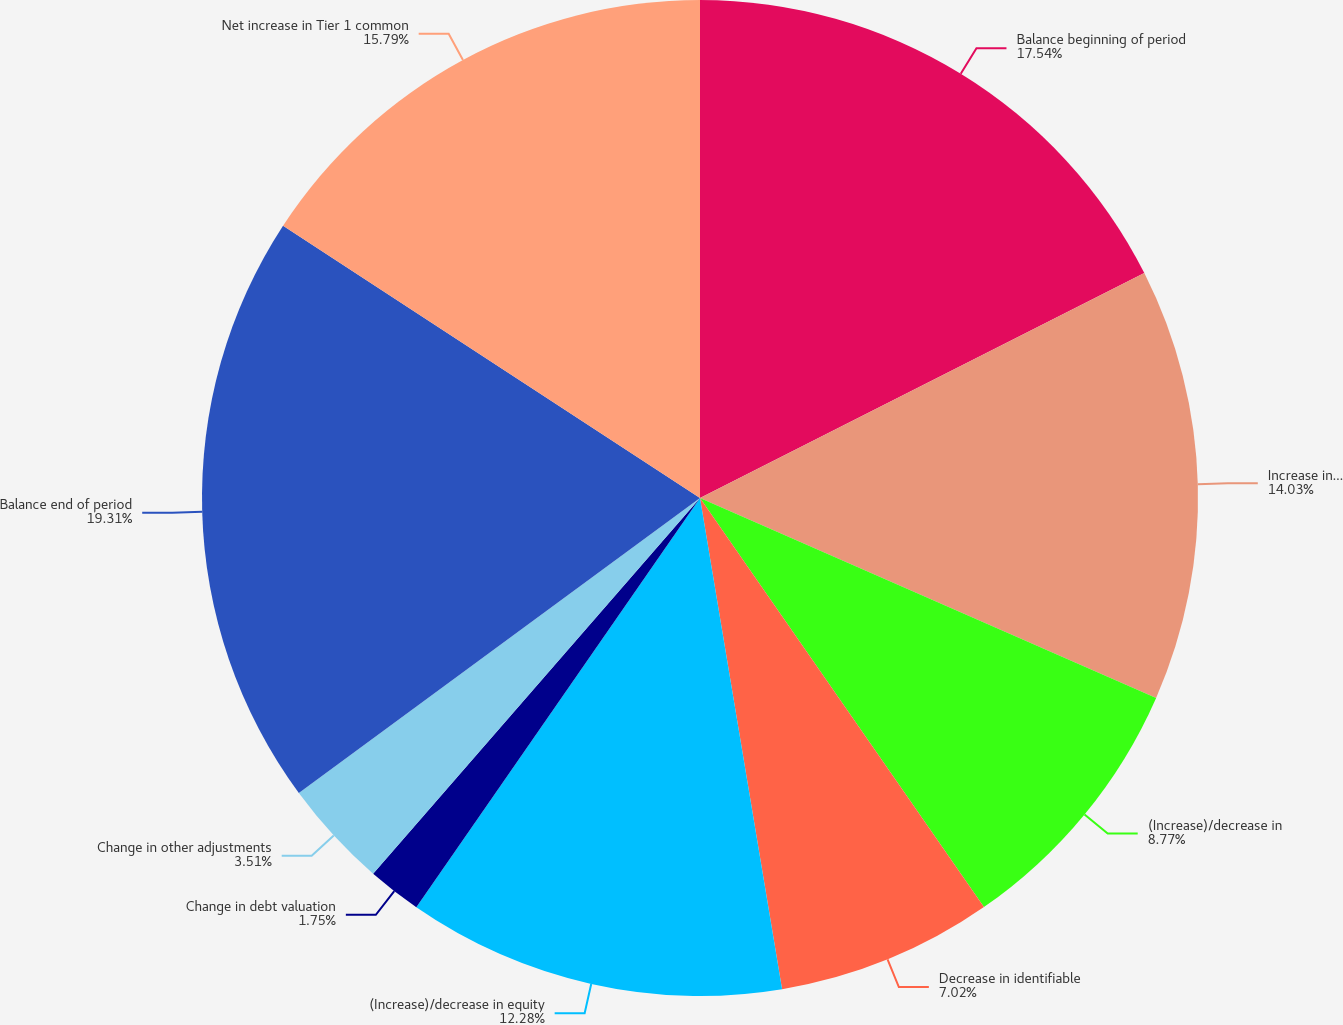Convert chart. <chart><loc_0><loc_0><loc_500><loc_500><pie_chart><fcel>Balance beginning of period<fcel>Increase in common<fcel>(Increase)/decrease in<fcel>Decrease in identifiable<fcel>(Increase)/decrease in equity<fcel>Change in debt valuation<fcel>Change in other adjustments<fcel>Balance end of period<fcel>Net increase in Tier 1 common<nl><fcel>17.54%<fcel>14.03%<fcel>8.77%<fcel>7.02%<fcel>12.28%<fcel>1.75%<fcel>3.51%<fcel>19.3%<fcel>15.79%<nl></chart> 